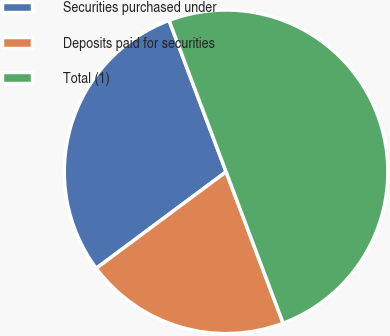Convert chart. <chart><loc_0><loc_0><loc_500><loc_500><pie_chart><fcel>Securities purchased under<fcel>Deposits paid for securities<fcel>Total (1)<nl><fcel>29.44%<fcel>20.56%<fcel>50.0%<nl></chart> 